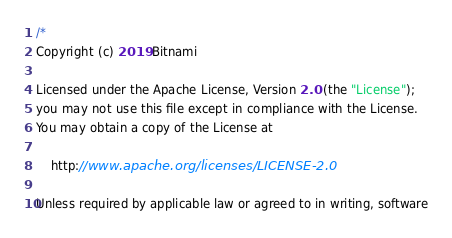Convert code to text. <code><loc_0><loc_0><loc_500><loc_500><_Go_>/*
Copyright (c) 2019 Bitnami

Licensed under the Apache License, Version 2.0 (the "License");
you may not use this file except in compliance with the License.
You may obtain a copy of the License at

    http://www.apache.org/licenses/LICENSE-2.0

Unless required by applicable law or agreed to in writing, software</code> 